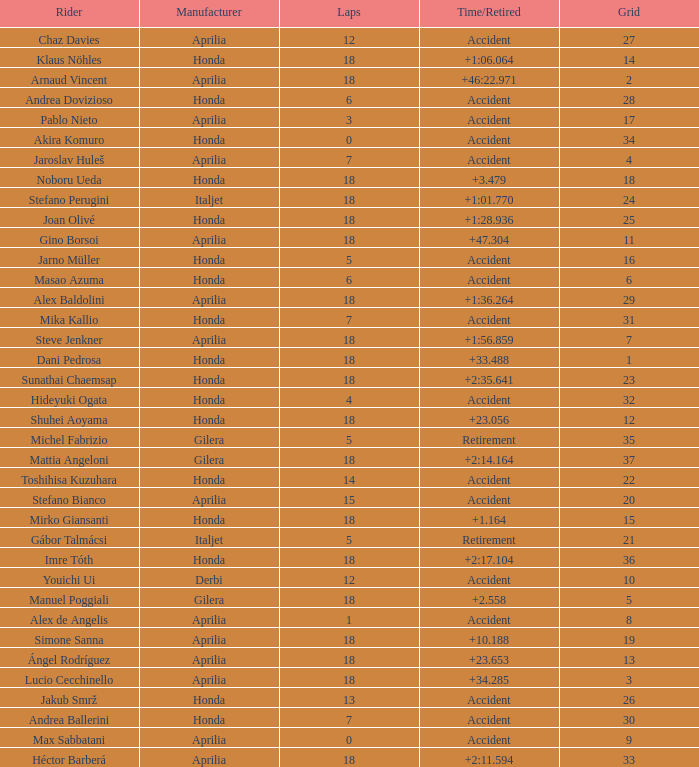What is the time/retired of the honda manufacturer with a grid less than 26, 18 laps, and joan olivé as the rider? +1:28.936. 